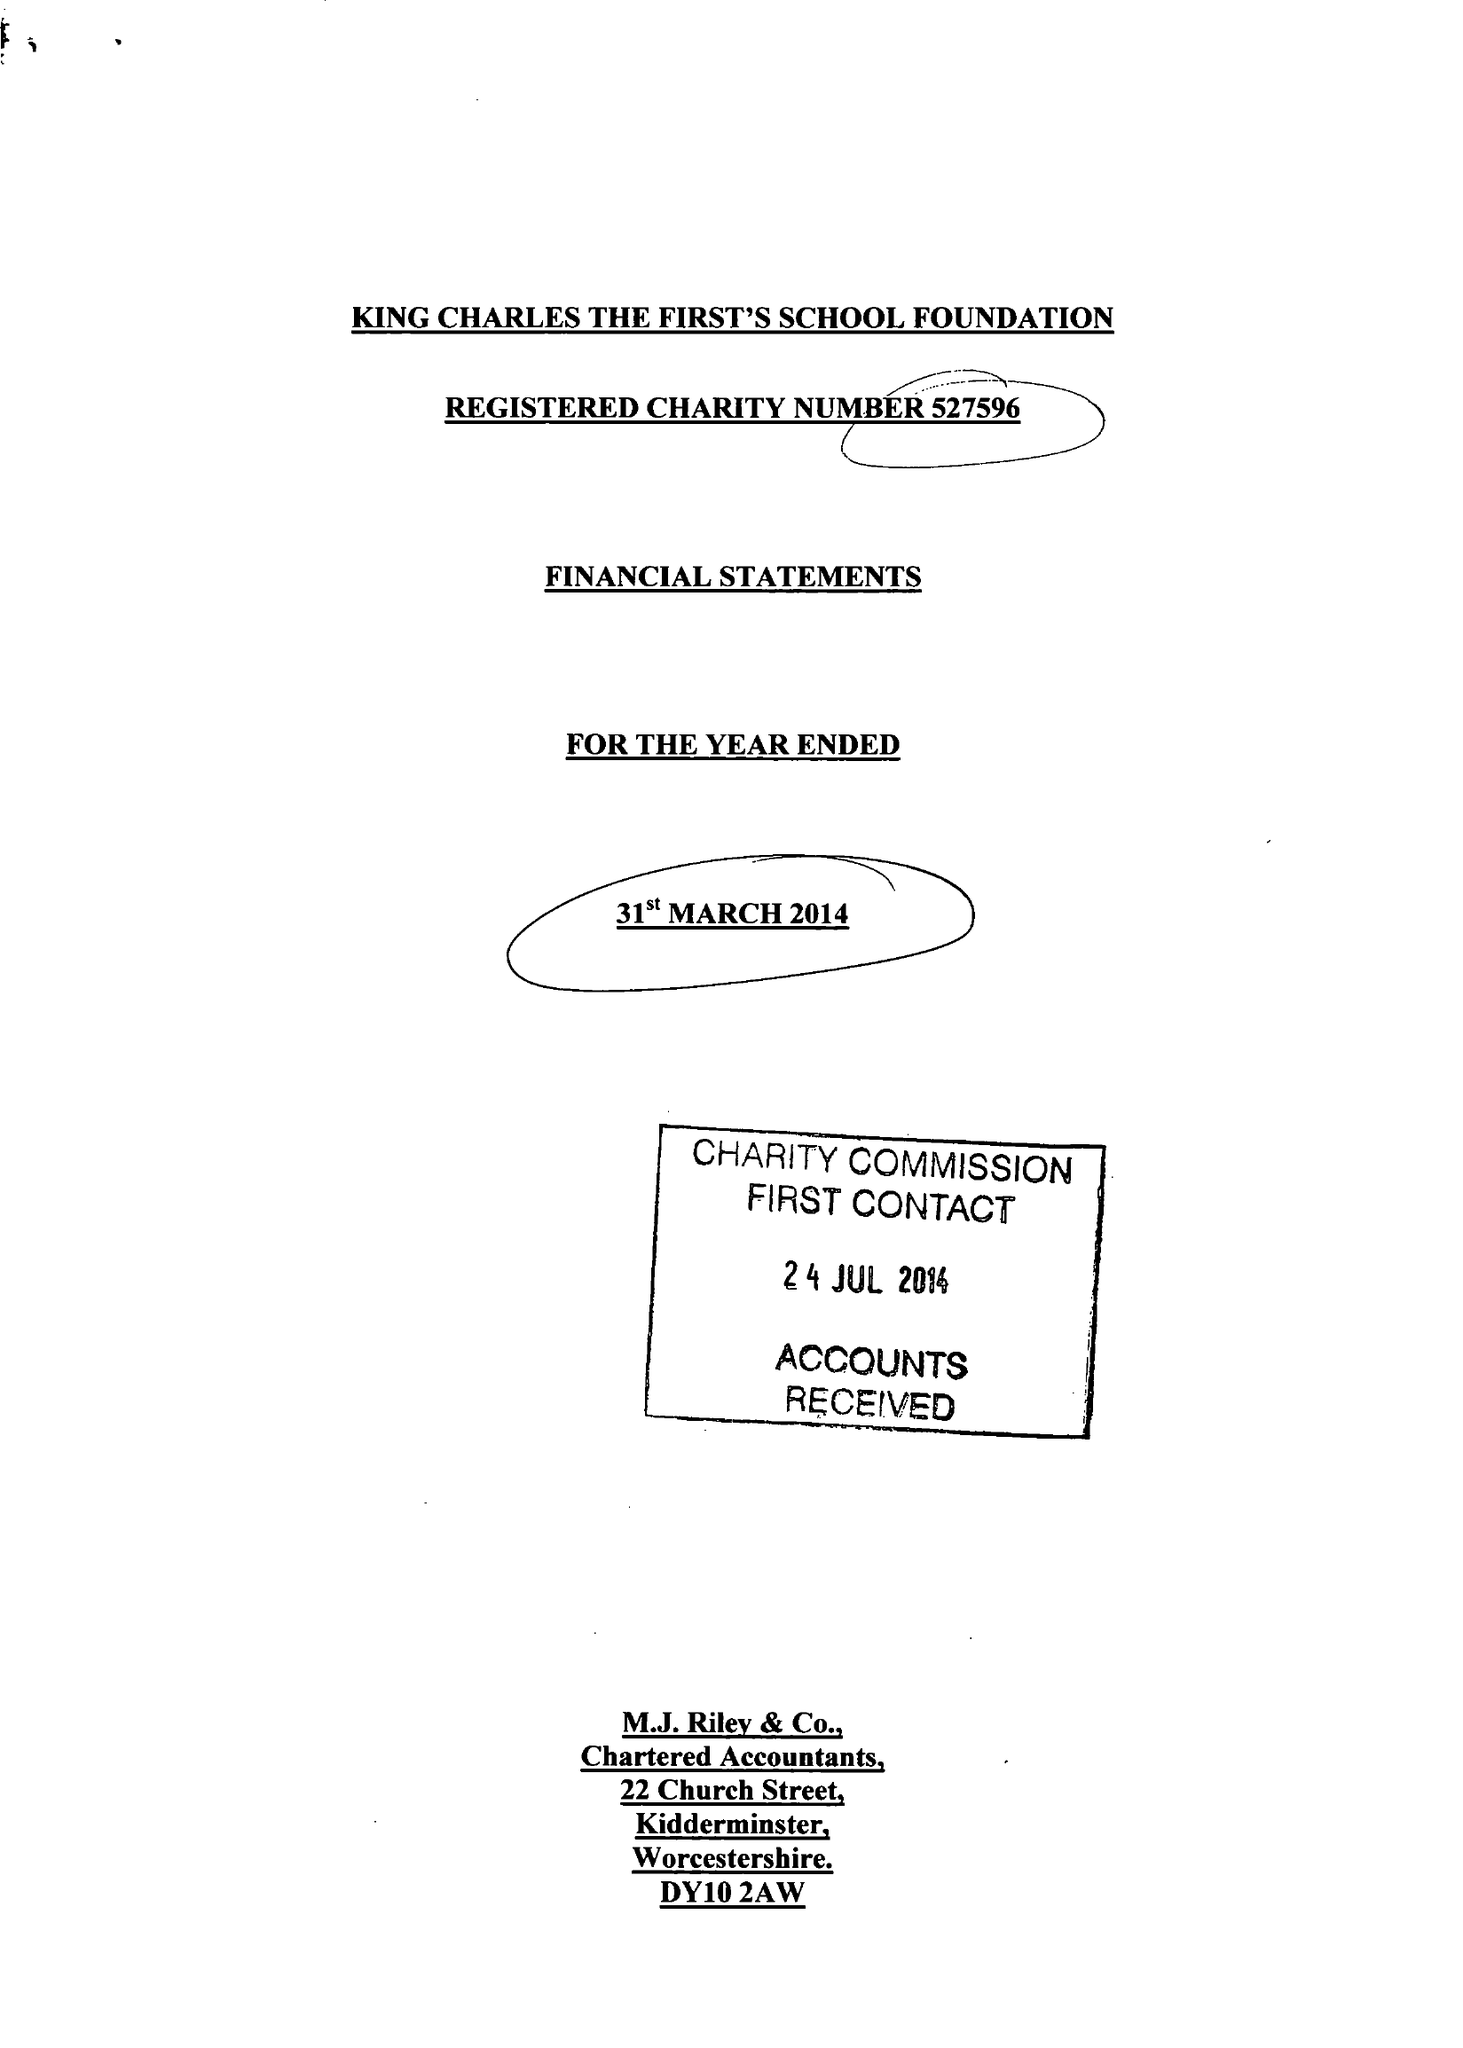What is the value for the address__street_line?
Answer the question using a single word or phrase. WILDEN TOP ROAD 